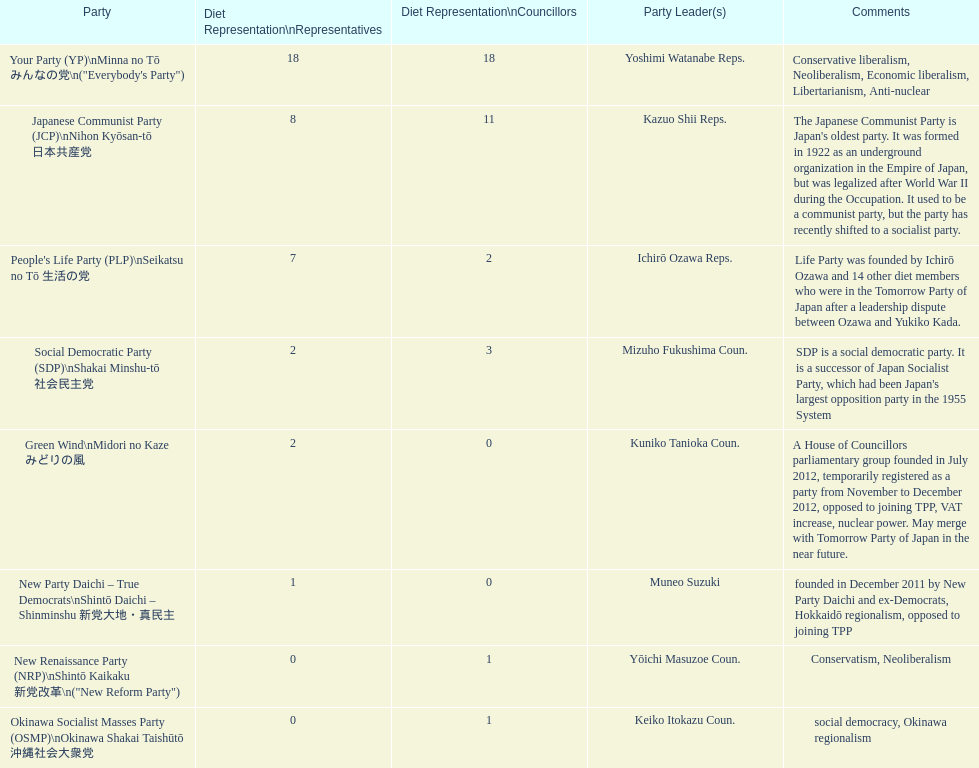What party comes prior to the new renaissance party? New Party Daichi - True Democrats. 